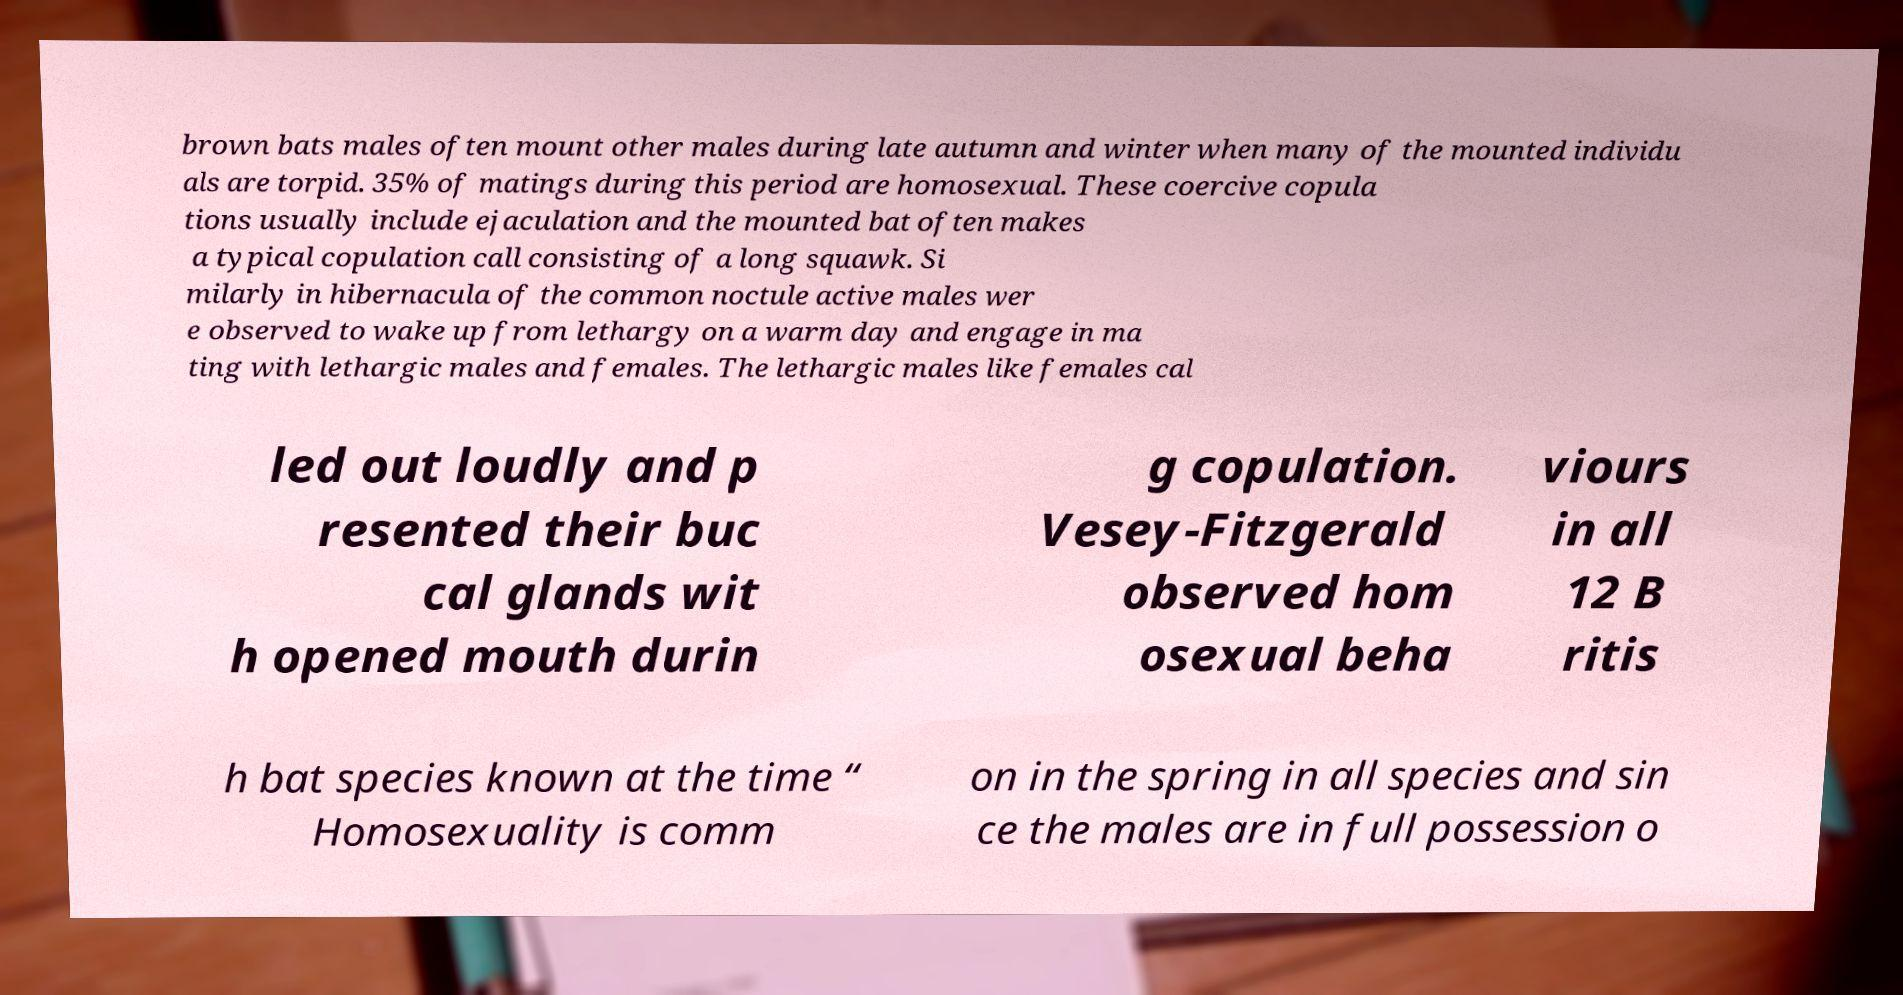Could you extract and type out the text from this image? brown bats males often mount other males during late autumn and winter when many of the mounted individu als are torpid. 35% of matings during this period are homosexual. These coercive copula tions usually include ejaculation and the mounted bat often makes a typical copulation call consisting of a long squawk. Si milarly in hibernacula of the common noctule active males wer e observed to wake up from lethargy on a warm day and engage in ma ting with lethargic males and females. The lethargic males like females cal led out loudly and p resented their buc cal glands wit h opened mouth durin g copulation. Vesey-Fitzgerald observed hom osexual beha viours in all 12 B ritis h bat species known at the time “ Homosexuality is comm on in the spring in all species and sin ce the males are in full possession o 